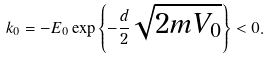<formula> <loc_0><loc_0><loc_500><loc_500>k _ { 0 } = - E _ { 0 } \exp \left \{ - \frac { d } { 2 } \sqrt { 2 m V _ { 0 } } \right \} < 0 .</formula> 